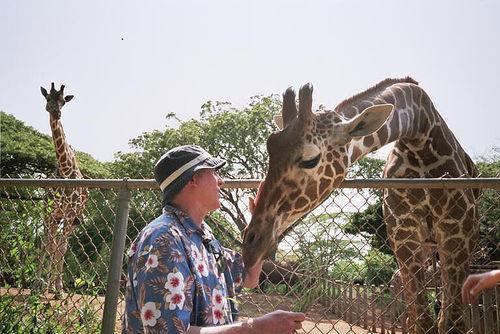Where is the giraffe's tongue?
Concise answer only. Sticking out. What kind of shirt is the man wearing?
Concise answer only. Hawaiian. Is he wearing a suit?
Be succinct. No. What are the giraffes eating?
Short answer required. Grass. Is the giraffe foraging?
Quick response, please. No. Are these giraffes wild?
Give a very brief answer. No. How many people wearing hats?
Keep it brief. 1. What is the fence made out of?
Keep it brief. Metal. 